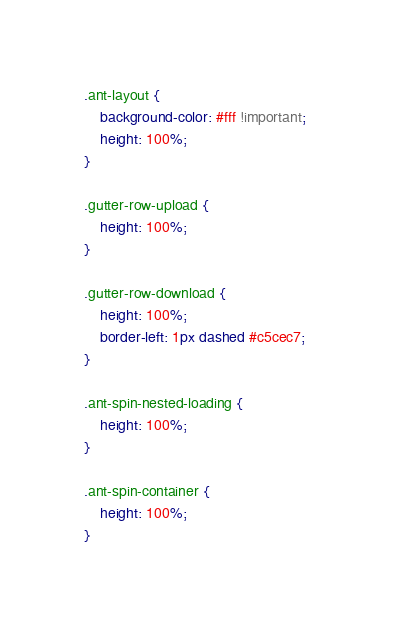<code> <loc_0><loc_0><loc_500><loc_500><_CSS_>.ant-layout {
    background-color: #fff !important;
    height: 100%;
}

.gutter-row-upload {
    height: 100%;
}

.gutter-row-download {
    height: 100%;
    border-left: 1px dashed #c5cec7; 
}

.ant-spin-nested-loading {
    height: 100%;
}

.ant-spin-container {
    height: 100%;
}</code> 